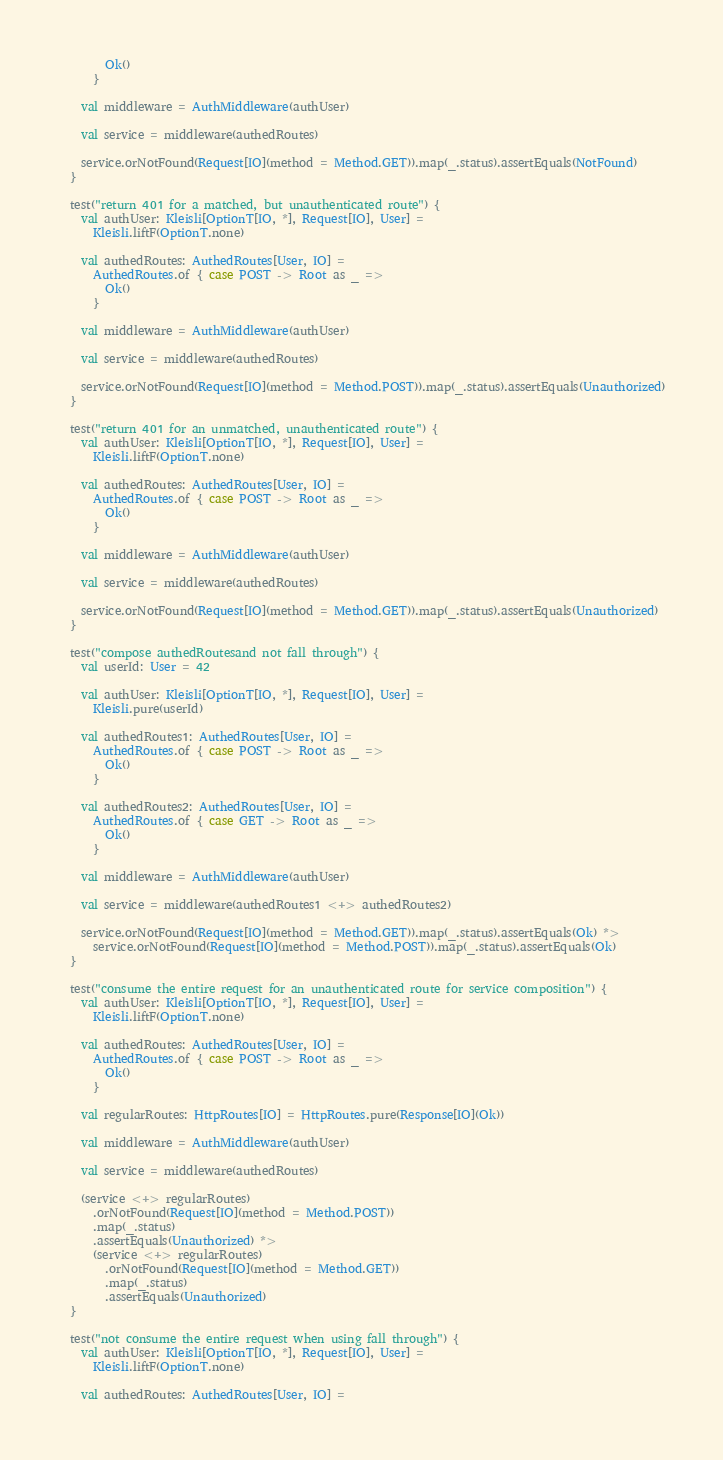<code> <loc_0><loc_0><loc_500><loc_500><_Scala_>        Ok()
      }

    val middleware = AuthMiddleware(authUser)

    val service = middleware(authedRoutes)

    service.orNotFound(Request[IO](method = Method.GET)).map(_.status).assertEquals(NotFound)
  }

  test("return 401 for a matched, but unauthenticated route") {
    val authUser: Kleisli[OptionT[IO, *], Request[IO], User] =
      Kleisli.liftF(OptionT.none)

    val authedRoutes: AuthedRoutes[User, IO] =
      AuthedRoutes.of { case POST -> Root as _ =>
        Ok()
      }

    val middleware = AuthMiddleware(authUser)

    val service = middleware(authedRoutes)

    service.orNotFound(Request[IO](method = Method.POST)).map(_.status).assertEquals(Unauthorized)
  }

  test("return 401 for an unmatched, unauthenticated route") {
    val authUser: Kleisli[OptionT[IO, *], Request[IO], User] =
      Kleisli.liftF(OptionT.none)

    val authedRoutes: AuthedRoutes[User, IO] =
      AuthedRoutes.of { case POST -> Root as _ =>
        Ok()
      }

    val middleware = AuthMiddleware(authUser)

    val service = middleware(authedRoutes)

    service.orNotFound(Request[IO](method = Method.GET)).map(_.status).assertEquals(Unauthorized)
  }

  test("compose authedRoutesand not fall through") {
    val userId: User = 42

    val authUser: Kleisli[OptionT[IO, *], Request[IO], User] =
      Kleisli.pure(userId)

    val authedRoutes1: AuthedRoutes[User, IO] =
      AuthedRoutes.of { case POST -> Root as _ =>
        Ok()
      }

    val authedRoutes2: AuthedRoutes[User, IO] =
      AuthedRoutes.of { case GET -> Root as _ =>
        Ok()
      }

    val middleware = AuthMiddleware(authUser)

    val service = middleware(authedRoutes1 <+> authedRoutes2)

    service.orNotFound(Request[IO](method = Method.GET)).map(_.status).assertEquals(Ok) *>
      service.orNotFound(Request[IO](method = Method.POST)).map(_.status).assertEquals(Ok)
  }

  test("consume the entire request for an unauthenticated route for service composition") {
    val authUser: Kleisli[OptionT[IO, *], Request[IO], User] =
      Kleisli.liftF(OptionT.none)

    val authedRoutes: AuthedRoutes[User, IO] =
      AuthedRoutes.of { case POST -> Root as _ =>
        Ok()
      }

    val regularRoutes: HttpRoutes[IO] = HttpRoutes.pure(Response[IO](Ok))

    val middleware = AuthMiddleware(authUser)

    val service = middleware(authedRoutes)

    (service <+> regularRoutes)
      .orNotFound(Request[IO](method = Method.POST))
      .map(_.status)
      .assertEquals(Unauthorized) *>
      (service <+> regularRoutes)
        .orNotFound(Request[IO](method = Method.GET))
        .map(_.status)
        .assertEquals(Unauthorized)
  }

  test("not consume the entire request when using fall through") {
    val authUser: Kleisli[OptionT[IO, *], Request[IO], User] =
      Kleisli.liftF(OptionT.none)

    val authedRoutes: AuthedRoutes[User, IO] =</code> 